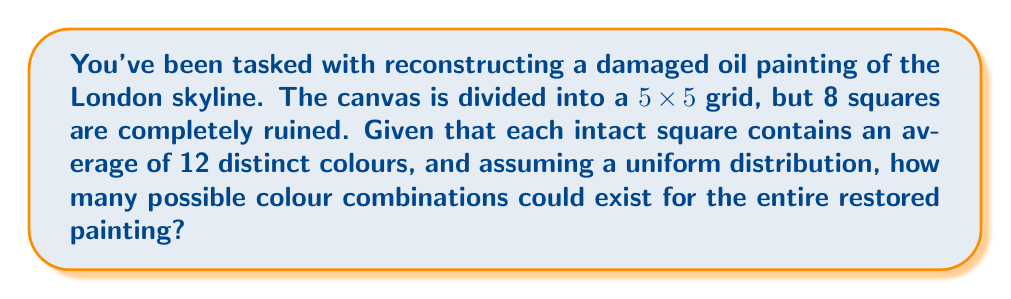Teach me how to tackle this problem. Let's approach this step-by-step:

1) First, we need to determine how many squares are intact:
   Total squares: $5 \times 5 = 25$
   Ruined squares: 8
   Intact squares: $25 - 8 = 17$

2) Each intact square contains an average of 12 distinct colours.

3) For each intact square, we have 12 choices for colour. This is repeated for all 17 intact squares.

4) The number of possible combinations is therefore:
   $12^{17}$

5) To calculate this:
   $$12^{17} = 2.218 \times 10^{18}$$

6) Rounding to 3 significant figures:
   $2.22 \times 10^{18}$

This astronomical number represents the possible colour combinations for the restored painting, assuming each square is filled independently. In reality, an artist would likely use context and style to narrow down the choices, but mathematically, this represents the total possible combinations.
Answer: $2.22 \times 10^{18}$ 